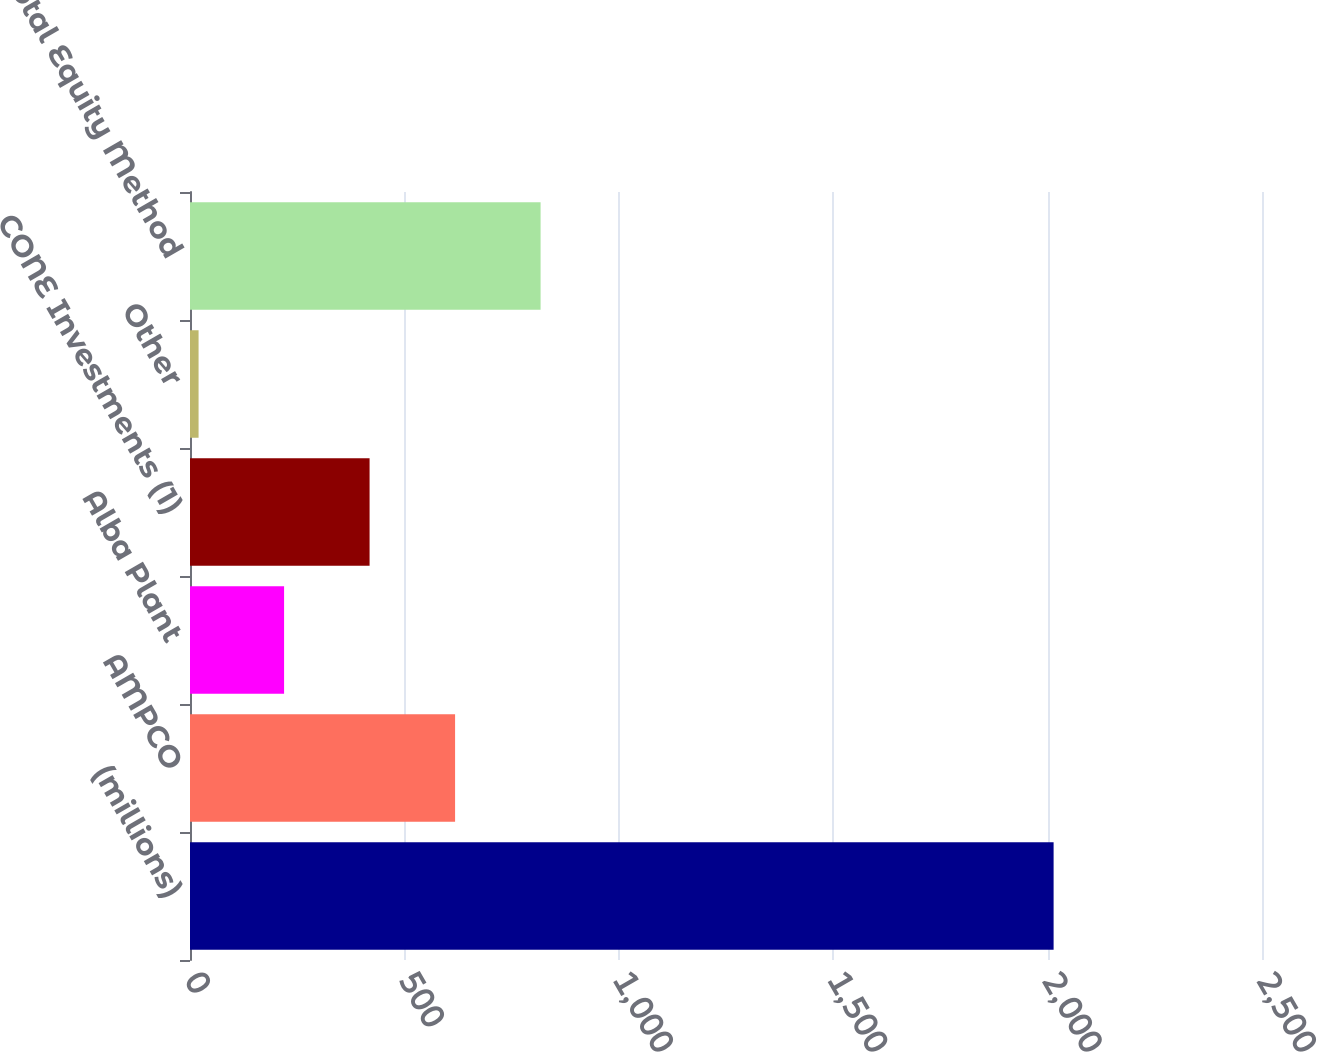Convert chart. <chart><loc_0><loc_0><loc_500><loc_500><bar_chart><fcel>(millions)<fcel>AMPCO<fcel>Alba Plant<fcel>CONE Investments (1)<fcel>Other<fcel>Total Equity Method<nl><fcel>2014<fcel>618.2<fcel>219.4<fcel>418.8<fcel>20<fcel>817.6<nl></chart> 